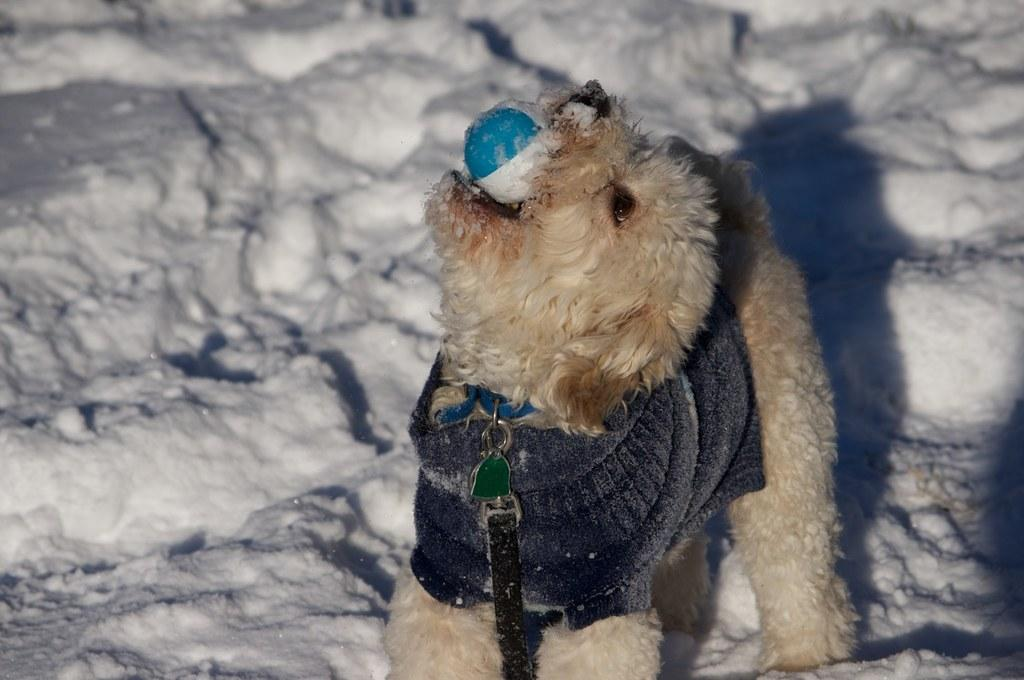What animal is present in the image? There is a dog in the image. What is the surface the dog is standing on? The dog is standing on the snow. What object is the dog holding in its mouth? The dog is holding a ball in its mouth. What accessory is the dog wearing around its neck? The dog has a belt around its neck. What grade is the dog in the image? The image does not mention or depict the dog being in a grade, as dogs do not attend school or have grades. 